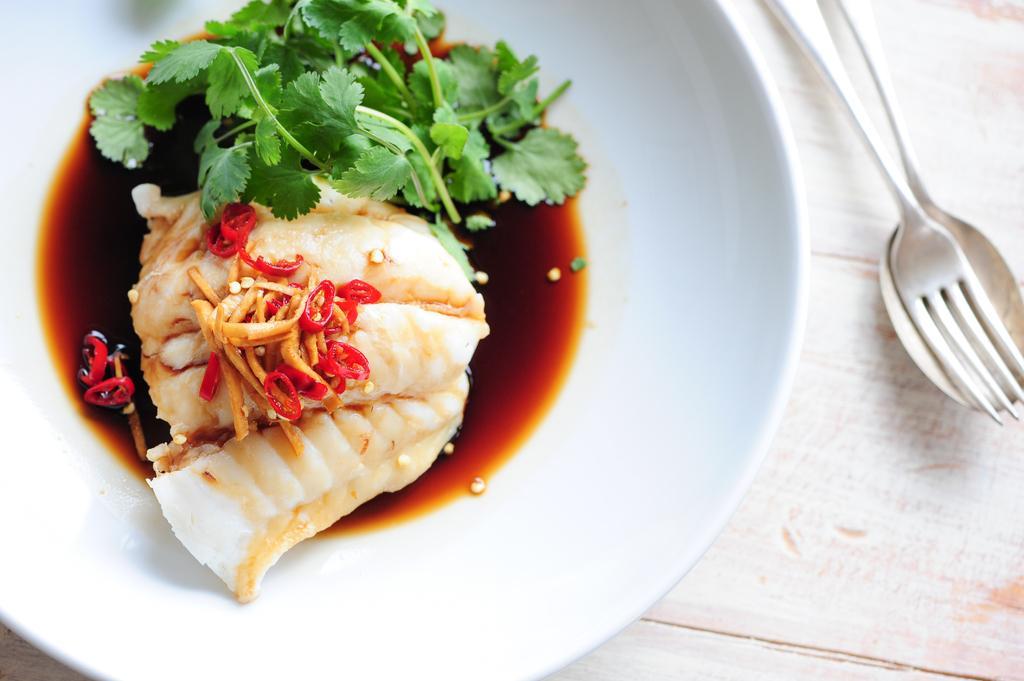How would you summarize this image in a sentence or two? In this image there is a plate and spoons beside it. In the plate there is sauce and coriander and chives and food in it. The plate is kept on the table. 